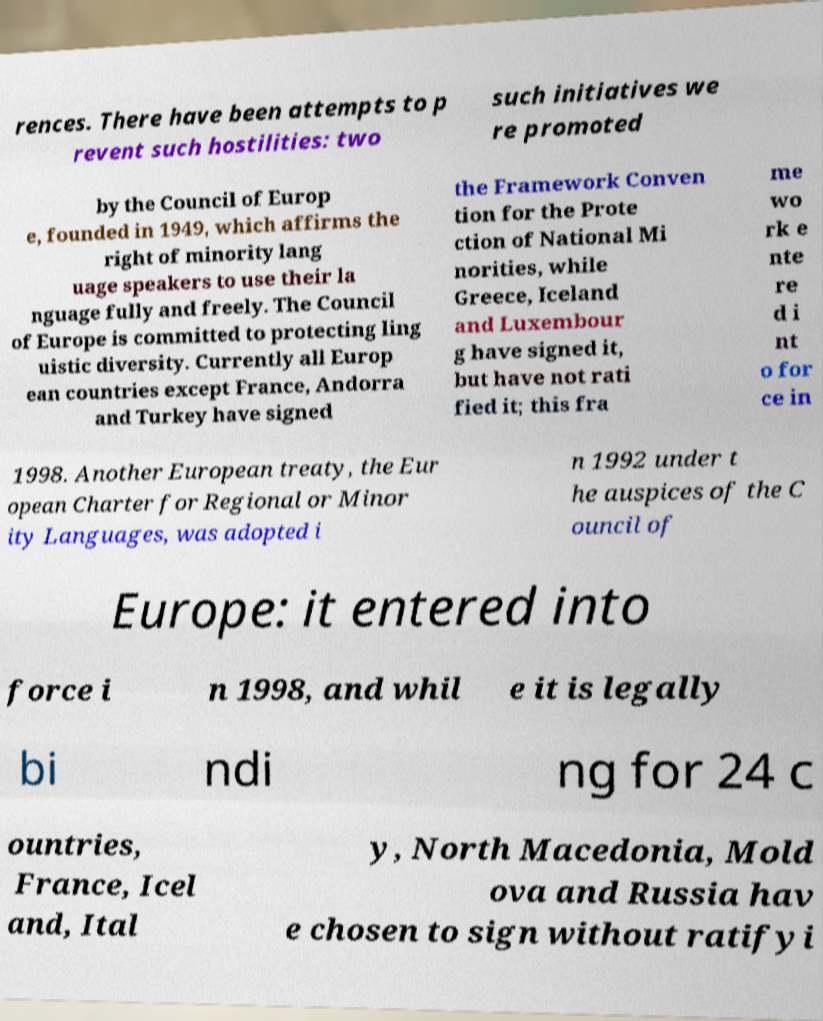Could you assist in decoding the text presented in this image and type it out clearly? rences. There have been attempts to p revent such hostilities: two such initiatives we re promoted by the Council of Europ e, founded in 1949, which affirms the right of minority lang uage speakers to use their la nguage fully and freely. The Council of Europe is committed to protecting ling uistic diversity. Currently all Europ ean countries except France, Andorra and Turkey have signed the Framework Conven tion for the Prote ction of National Mi norities, while Greece, Iceland and Luxembour g have signed it, but have not rati fied it; this fra me wo rk e nte re d i nt o for ce in 1998. Another European treaty, the Eur opean Charter for Regional or Minor ity Languages, was adopted i n 1992 under t he auspices of the C ouncil of Europe: it entered into force i n 1998, and whil e it is legally bi ndi ng for 24 c ountries, France, Icel and, Ital y, North Macedonia, Mold ova and Russia hav e chosen to sign without ratifyi 